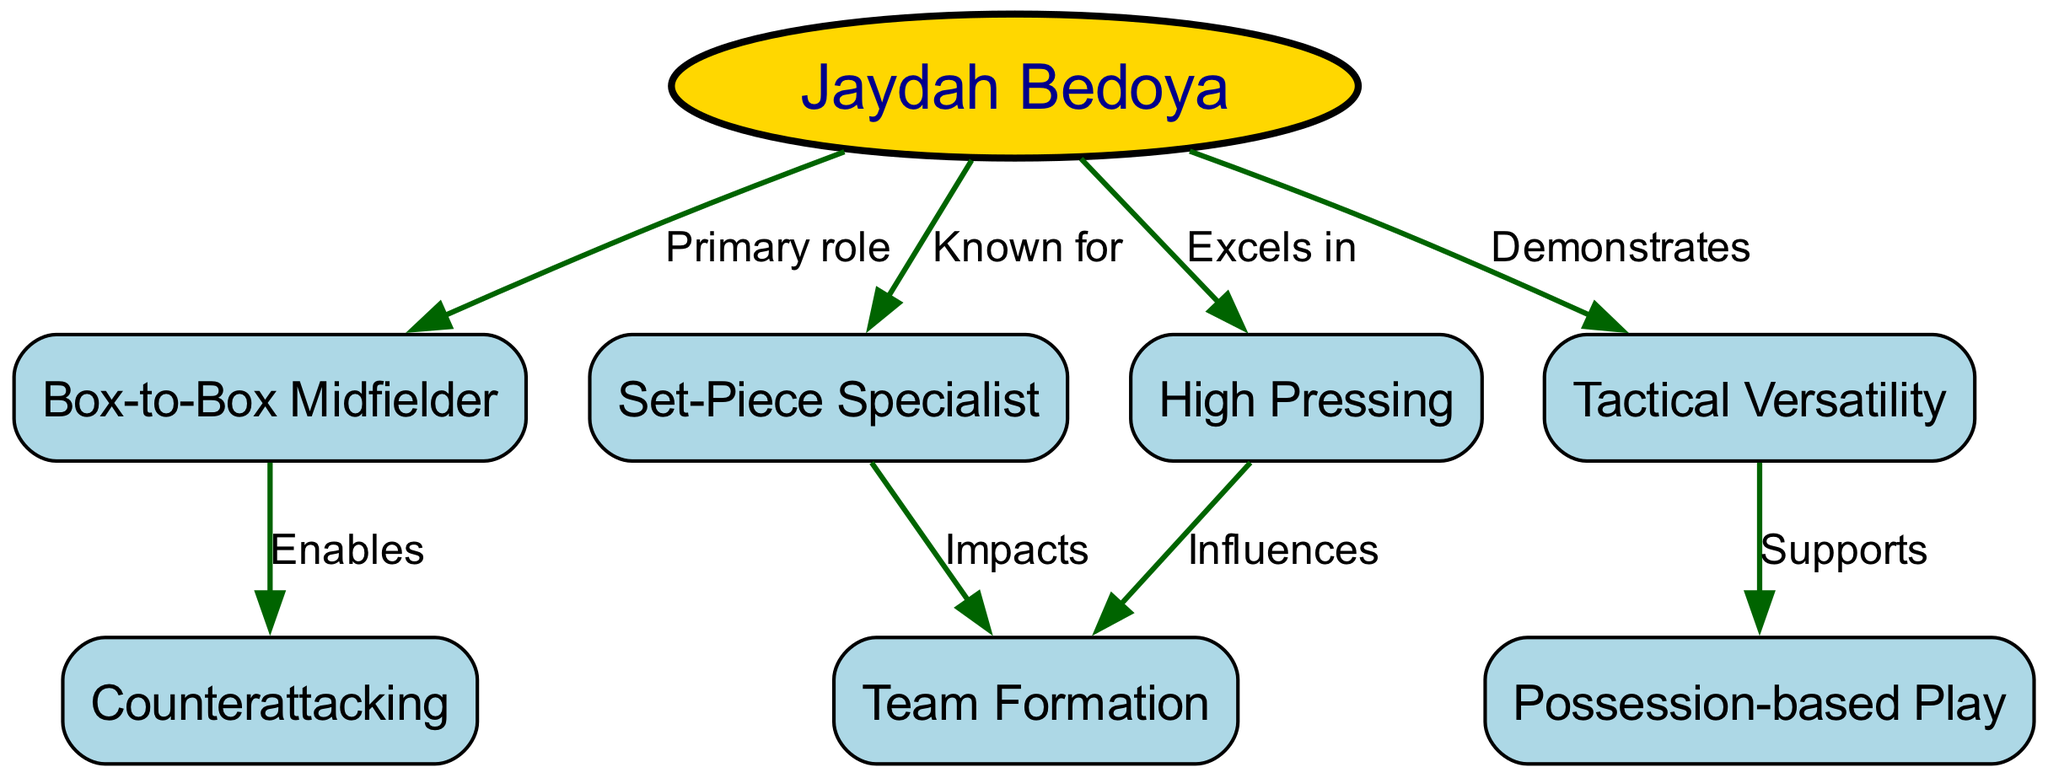What is Jaydah Bedoya's primary role on the team? The diagram indicates that Jaydah Bedoya has a direct connection labeled "Primary role" to the node "Box-to-Box Midfielder," which signifies her main position in the team setup.
Answer: Box-to-Box Midfielder How many nodes are in the diagram? By counting all the unique entities presented in the visual, we identify a total of eight separate nodes that capture various aspects of Jaydah Bedoya's tactical analysis and role.
Answer: 8 What tactical characteristic does Jaydah Bedoya excel in? The edge labeled "Excels in" connects her to the node "High Pressing," highlighting her skill in this area of the game.
Answer: High Pressing Which aspect of her play impacts team formation? The diagram shows that both "High Pressing" and "Set-Piece Specialist" are connected to "Team Formation," meaning these aspects influence how the team is structured on the field.
Answer: High Pressing, Set-Piece Specialist How does being a Box-to-Box Midfielder affect counterattacking? The node "Box-to-Box Midfielder" has a connection labeled "Enables" to "Counterattacking," suggesting that her ability in this position facilitates swift transitions and offensive plays.
Answer: Enables What role does Tactical Versatility play in possession-based play? The connection labeled "Supports" between "Tactical Versatility" and "Possession-based Play" indicates that her flexibility in tactics aids the team's focus on maintaining ball control and structured play.
Answer: Supports What tactical approach does High Pressing influence? The edge from "High Pressing" to "Team Formation" shows that her high-intensity pressing style has an impact on the formation used by the team during matches.
Answer: Team Formation Which node is connected to Jaydah Bedoya as 'known for'? The link from "Jaydah Bedoya" to the node "Set-Piece Specialist" specifically identifies her reputation in this area, suggesting a particular talent for executing set plays.
Answer: Set-Piece Specialist 